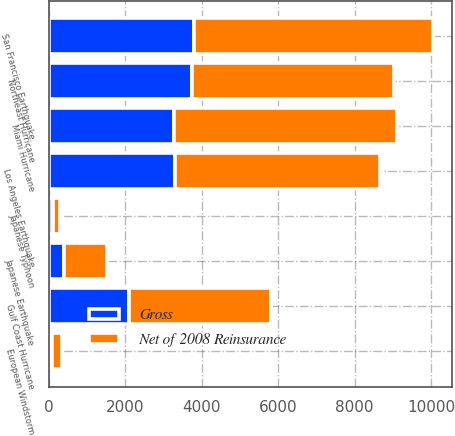Convert chart. <chart><loc_0><loc_0><loc_500><loc_500><stacked_bar_chart><ecel><fcel>San Francisco Earthquake<fcel>Miami Hurricane<fcel>Northeast Hurricane<fcel>Los Angeles Earthquake<fcel>Gulf Coast Hurricane<fcel>Japanese Earthquake<fcel>European Windstorm<fcel>Japanese Typhoon<nl><fcel>Net of 2008 Reinsurance<fcel>6236<fcel>5829<fcel>5287<fcel>5375<fcel>3730<fcel>1109<fcel>252<fcel>177<nl><fcel>Gross<fcel>3809<fcel>3280<fcel>3739<fcel>3297<fcel>2088<fcel>406<fcel>89<fcel>103<nl></chart> 